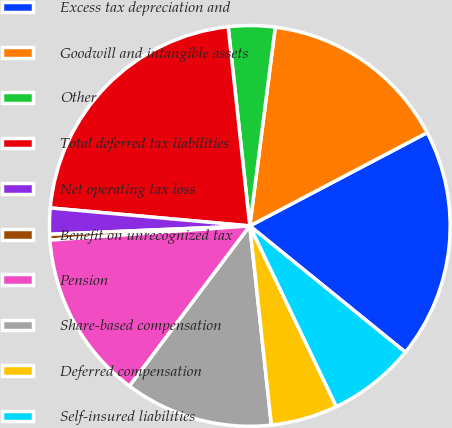Convert chart. <chart><loc_0><loc_0><loc_500><loc_500><pie_chart><fcel>Excess tax depreciation and<fcel>Goodwill and intangible assets<fcel>Other<fcel>Total deferred tax liabilities<fcel>Net operating tax loss<fcel>Benefit on unrecognized tax<fcel>Pension<fcel>Share-based compensation<fcel>Deferred compensation<fcel>Self-insured liabilities<nl><fcel>18.56%<fcel>15.27%<fcel>3.75%<fcel>21.85%<fcel>2.1%<fcel>0.46%<fcel>13.62%<fcel>11.97%<fcel>5.39%<fcel>7.04%<nl></chart> 